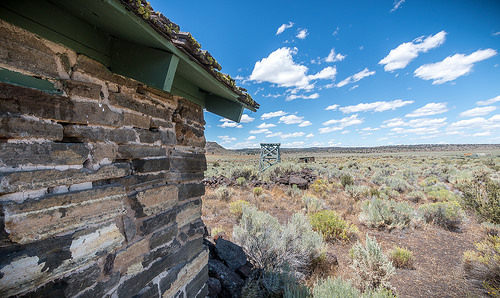<image>
Is there a sky behind the field? No. The sky is not behind the field. From this viewpoint, the sky appears to be positioned elsewhere in the scene. Where is the building in relation to the ground? Is it behind the ground? No. The building is not behind the ground. From this viewpoint, the building appears to be positioned elsewhere in the scene. 